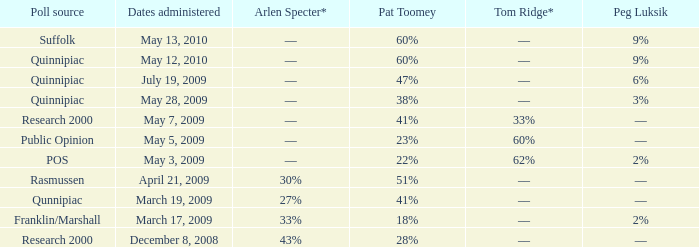In which poll source is peg luksik shown to have a 9% rating, and was carried out on may 12, 2010? Quinnipiac. 